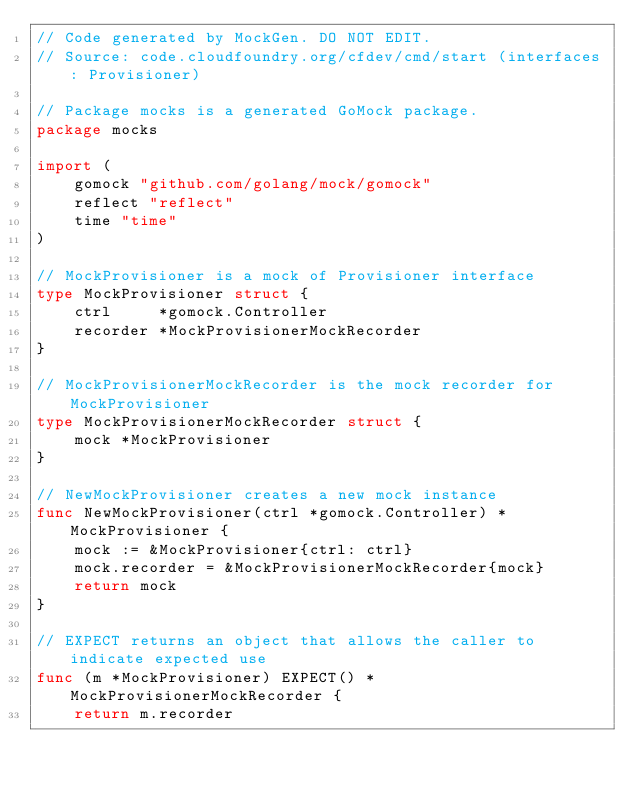<code> <loc_0><loc_0><loc_500><loc_500><_Go_>// Code generated by MockGen. DO NOT EDIT.
// Source: code.cloudfoundry.org/cfdev/cmd/start (interfaces: Provisioner)

// Package mocks is a generated GoMock package.
package mocks

import (
	gomock "github.com/golang/mock/gomock"
	reflect "reflect"
	time "time"
)

// MockProvisioner is a mock of Provisioner interface
type MockProvisioner struct {
	ctrl     *gomock.Controller
	recorder *MockProvisionerMockRecorder
}

// MockProvisionerMockRecorder is the mock recorder for MockProvisioner
type MockProvisionerMockRecorder struct {
	mock *MockProvisioner
}

// NewMockProvisioner creates a new mock instance
func NewMockProvisioner(ctrl *gomock.Controller) *MockProvisioner {
	mock := &MockProvisioner{ctrl: ctrl}
	mock.recorder = &MockProvisionerMockRecorder{mock}
	return mock
}

// EXPECT returns an object that allows the caller to indicate expected use
func (m *MockProvisioner) EXPECT() *MockProvisionerMockRecorder {
	return m.recorder</code> 